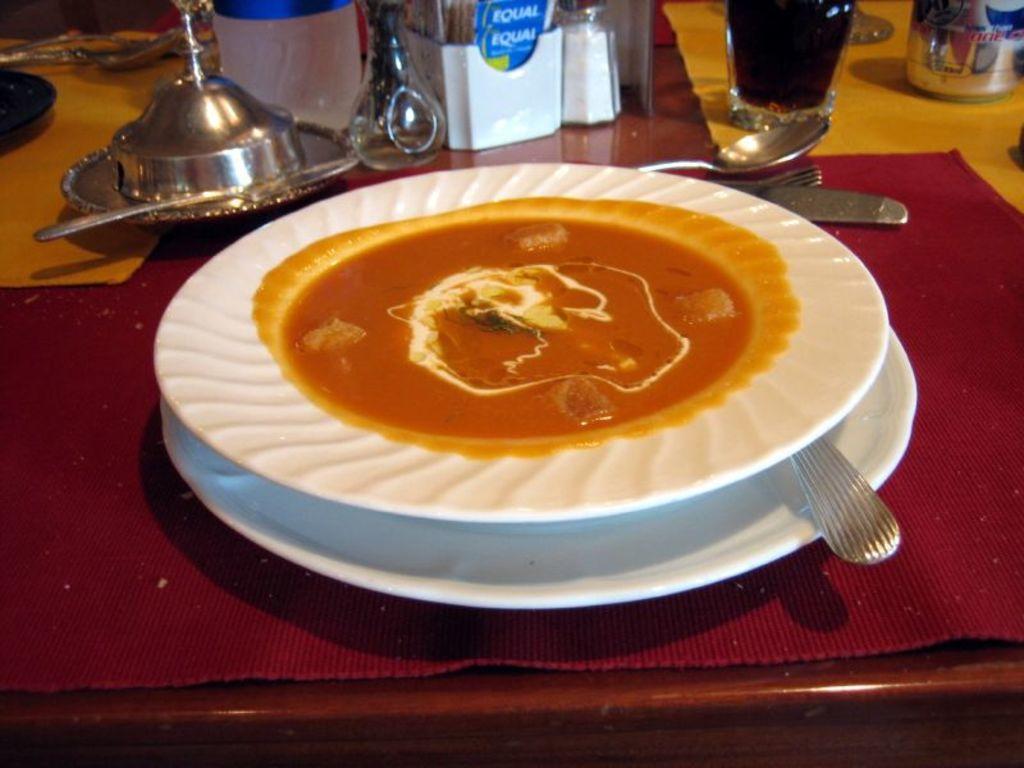How would you summarize this image in a sentence or two? In the picture I can see some food item is placed on the white color plate, here we can see spoons, forks, knives and a few more objects are placed on the table. 